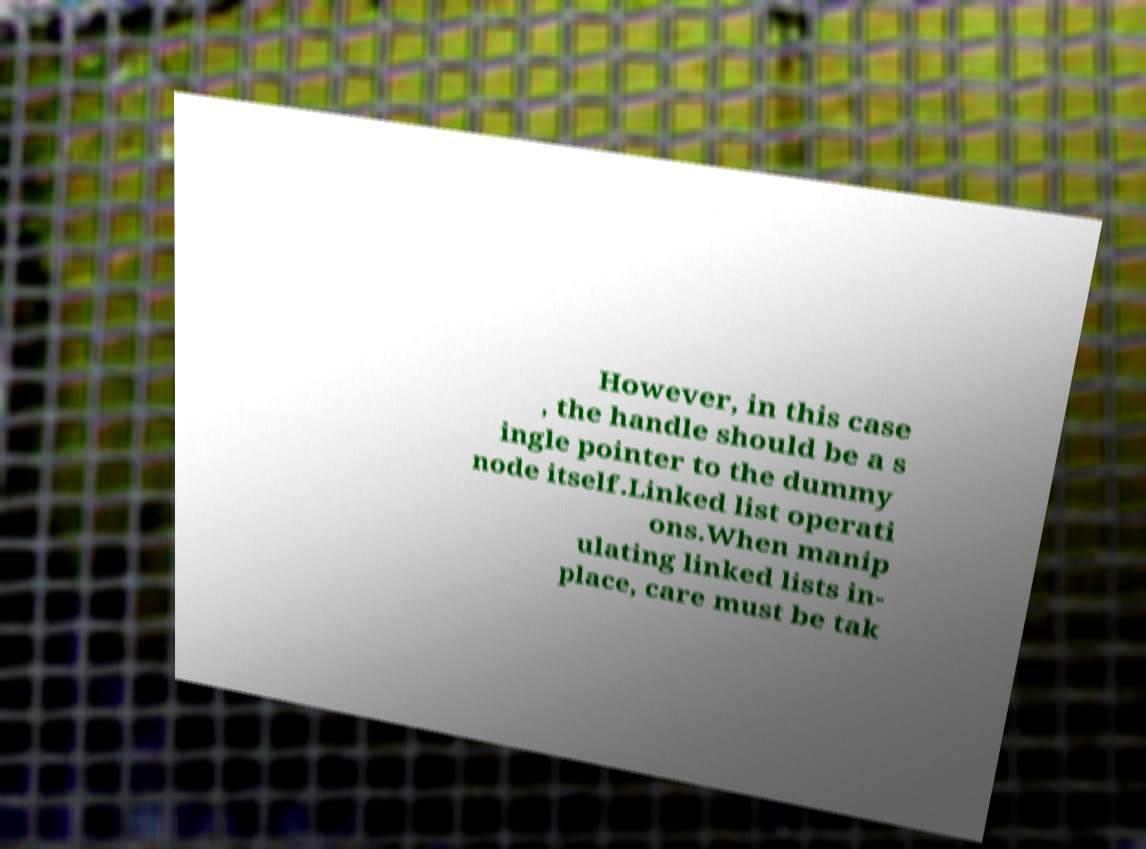Can you accurately transcribe the text from the provided image for me? However, in this case , the handle should be a s ingle pointer to the dummy node itself.Linked list operati ons.When manip ulating linked lists in- place, care must be tak 